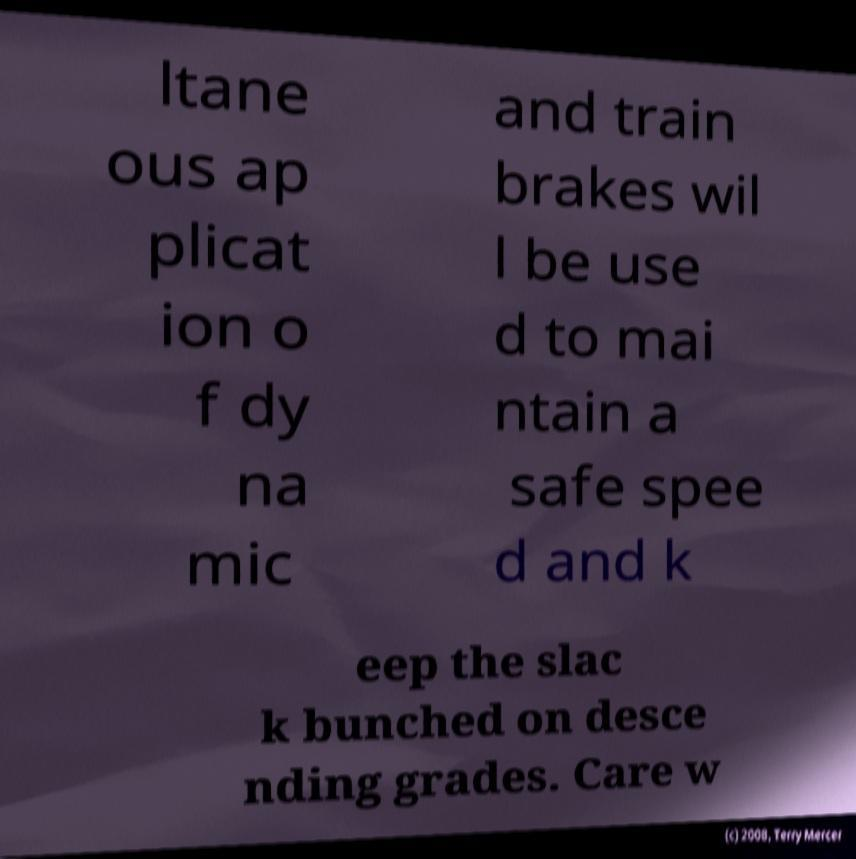Please read and relay the text visible in this image. What does it say? ltane ous ap plicat ion o f dy na mic and train brakes wil l be use d to mai ntain a safe spee d and k eep the slac k bunched on desce nding grades. Care w 